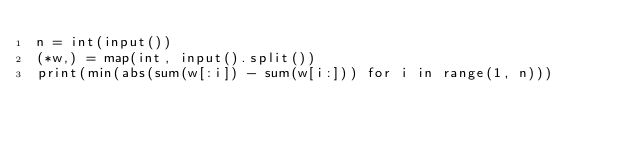Convert code to text. <code><loc_0><loc_0><loc_500><loc_500><_Python_>n = int(input())
(*w,) = map(int, input().split())
print(min(abs(sum(w[:i]) - sum(w[i:])) for i in range(1, n)))</code> 